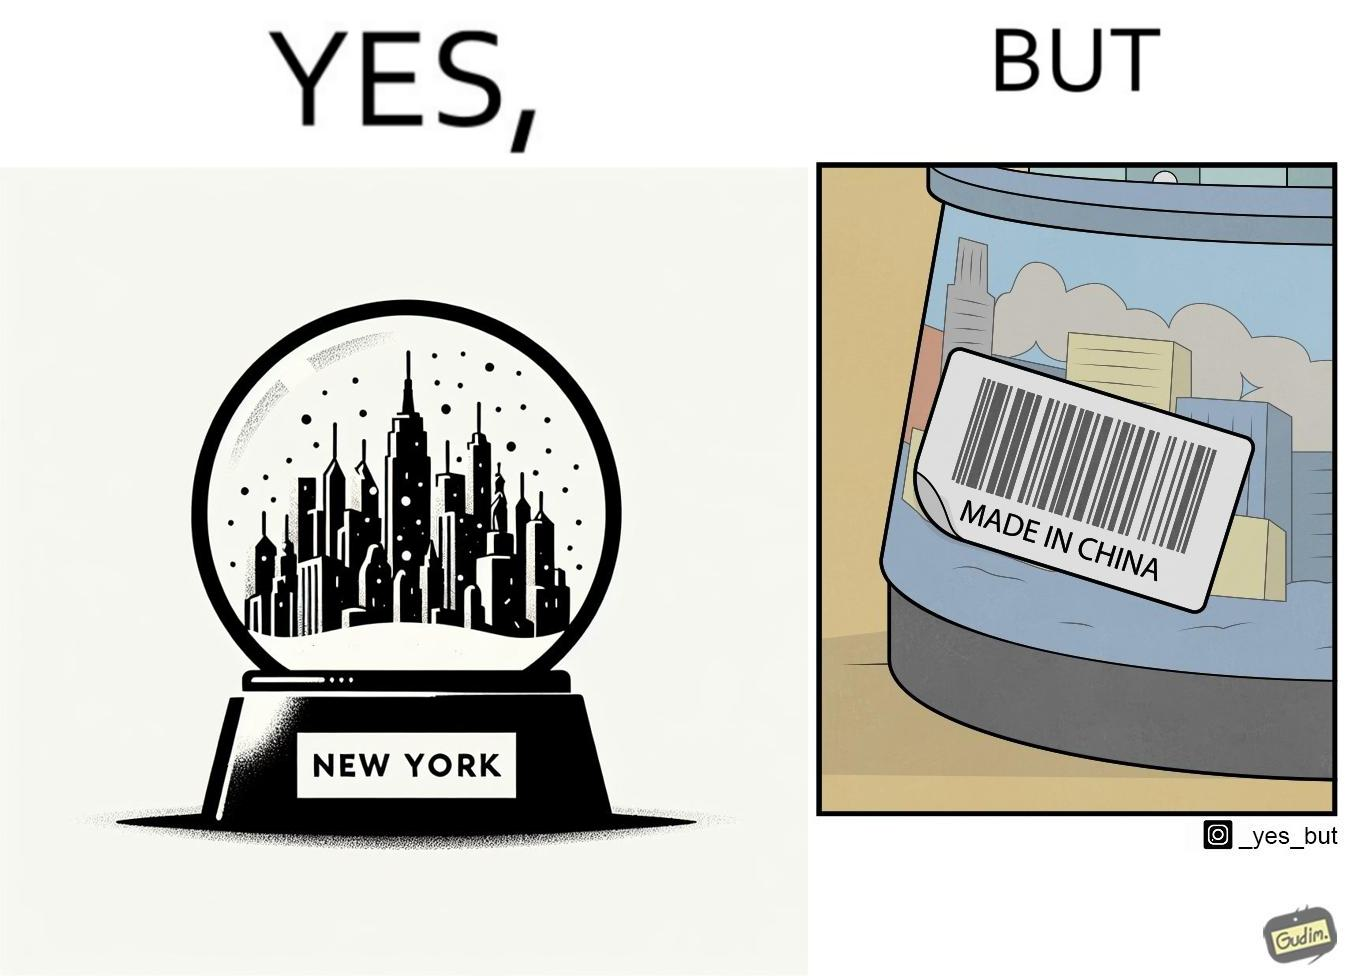What does this image depict? The image is ironic because the snowglobe says 'New York' while it is made in China 